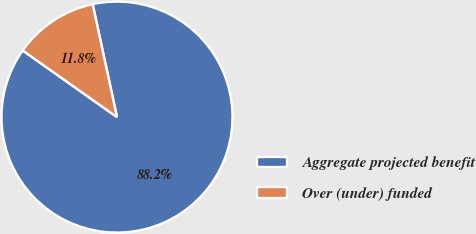Convert chart to OTSL. <chart><loc_0><loc_0><loc_500><loc_500><pie_chart><fcel>Aggregate projected benefit<fcel>Over (under) funded<nl><fcel>88.17%<fcel>11.83%<nl></chart> 